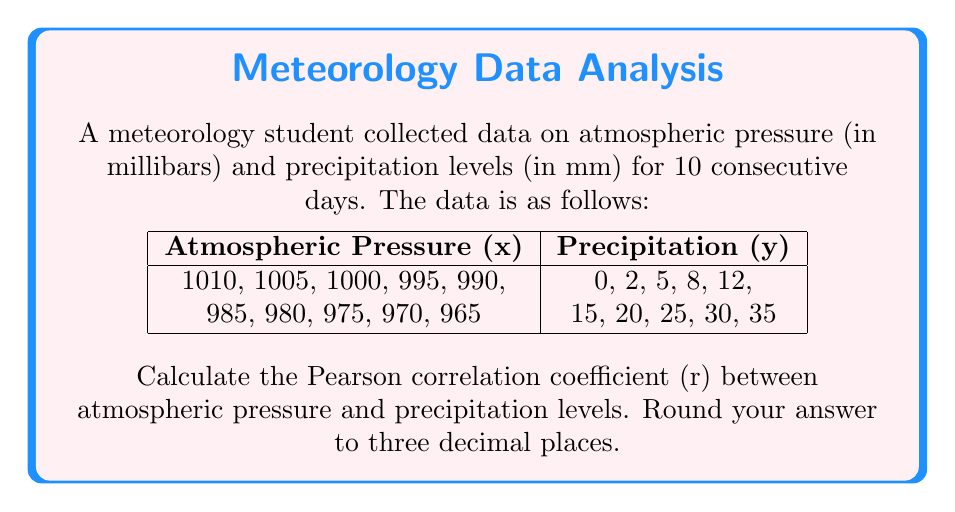Teach me how to tackle this problem. To calculate the Pearson correlation coefficient (r), we'll use the formula:

$$ r = \frac{n\sum xy - \sum x \sum y}{\sqrt{[n\sum x^2 - (\sum x)^2][n\sum y^2 - (\sum y)^2]}} $$

Where:
n = number of pairs of data
x = atmospheric pressure
y = precipitation levels

Step 1: Calculate the required sums:
n = 10
$\sum x = 9875$
$\sum y = 152$
$\sum xy = 1,498,250$
$\sum x^2 = 9,751,875$
$\sum y^2 = 4,202$

Step 2: Calculate $(\sum x)^2$ and $(\sum y)^2$:
$(\sum x)^2 = 97,515,625$
$(\sum y)^2 = 23,104$

Step 3: Substitute values into the formula:

$$ r = \frac{10(1,498,250) - (9875)(152)}{\sqrt{[10(9,751,875) - 97,515,625][10(4,202) - 23,104]}} $$

Step 4: Simplify:

$$ r = \frac{14,982,500 - 1,501,000}{\sqrt{(97,518,750 - 97,515,625)(42,020 - 23,104)}} $$

$$ r = \frac{13,481,500}{\sqrt{(3,125)(18,916)}} $$

$$ r = \frac{13,481,500}{\sqrt{59,112,500}} $$

$$ r = \frac{13,481,500}{7,688.468} $$

$$ r = -0.9992 $$

Step 5: Round to three decimal places:
r ≈ -0.999
Answer: -0.999 